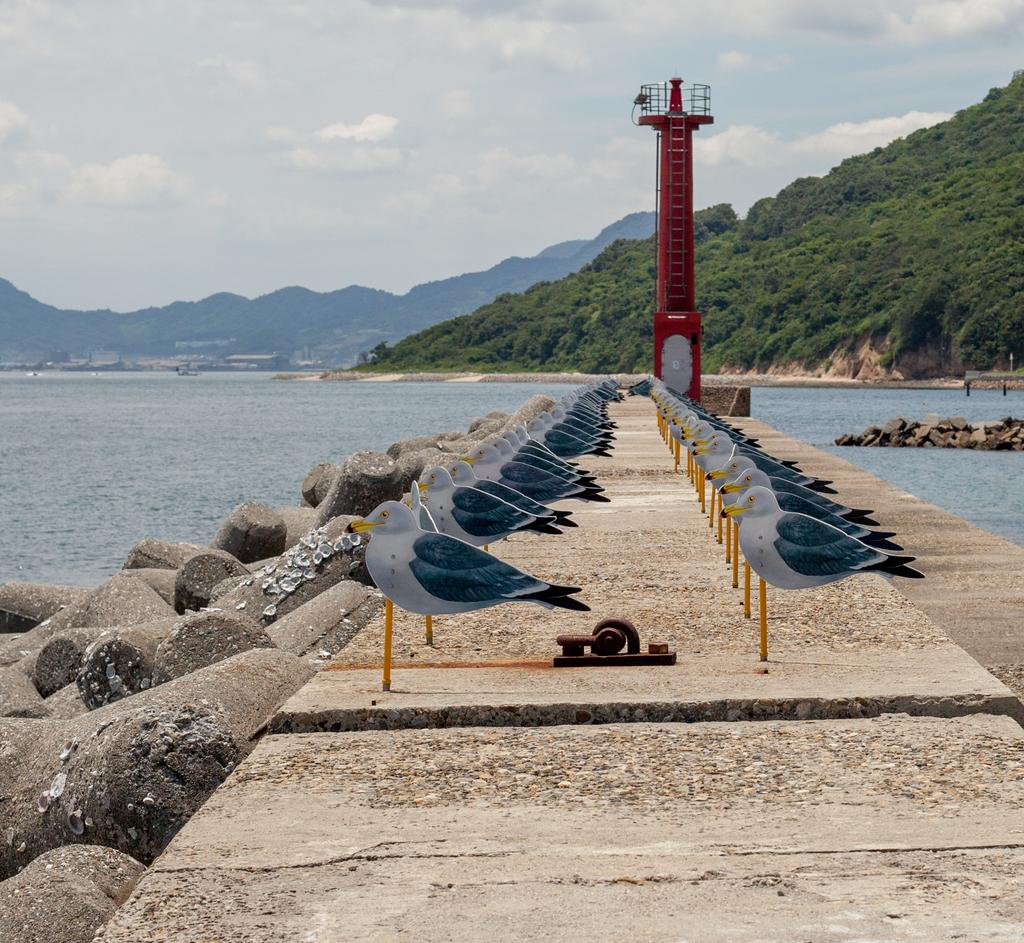What type of toys are present in the image? There are toy birds in the image. How are the toy birds positioned in the image? The toy birds are attached to an object. Where is the object with toy birds located? The object with toy birds is placed on the ground. What can be seen in the background of the image? There are mountains and water visible in the background of the image. What type of science experiment is being conducted with the toy birds in the image? There is no science experiment being conducted with the toy birds in the image; they are simply attached to an object. Is there a boot visible in the image? No, there is no boot present in the image. 